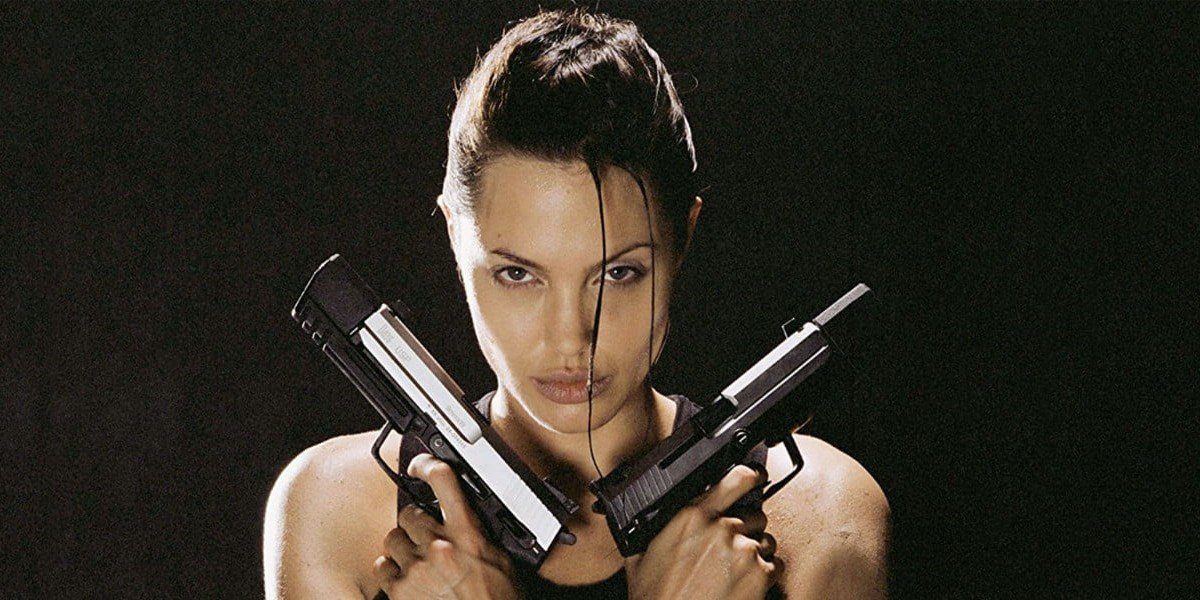What is this photo about? This compelling image captures Angelina Jolie in her role as Lara Croft in the film 'Tomb Raider', one of the pioneering movies that blended action and adventure with a strong female lead. Jolie's portrayal of Lara Croft, with her poised and confident stance holding two guns crossed in front of her chest, became iconic. Her outfit, a simple black tank top, and her hair styled in a messy bun, underscore her rugged and resolute character. The dark backdrop and moody lighting further accentuate her formidable presence, showcasing the blend of strength and mystique that defines Lara Croft. 